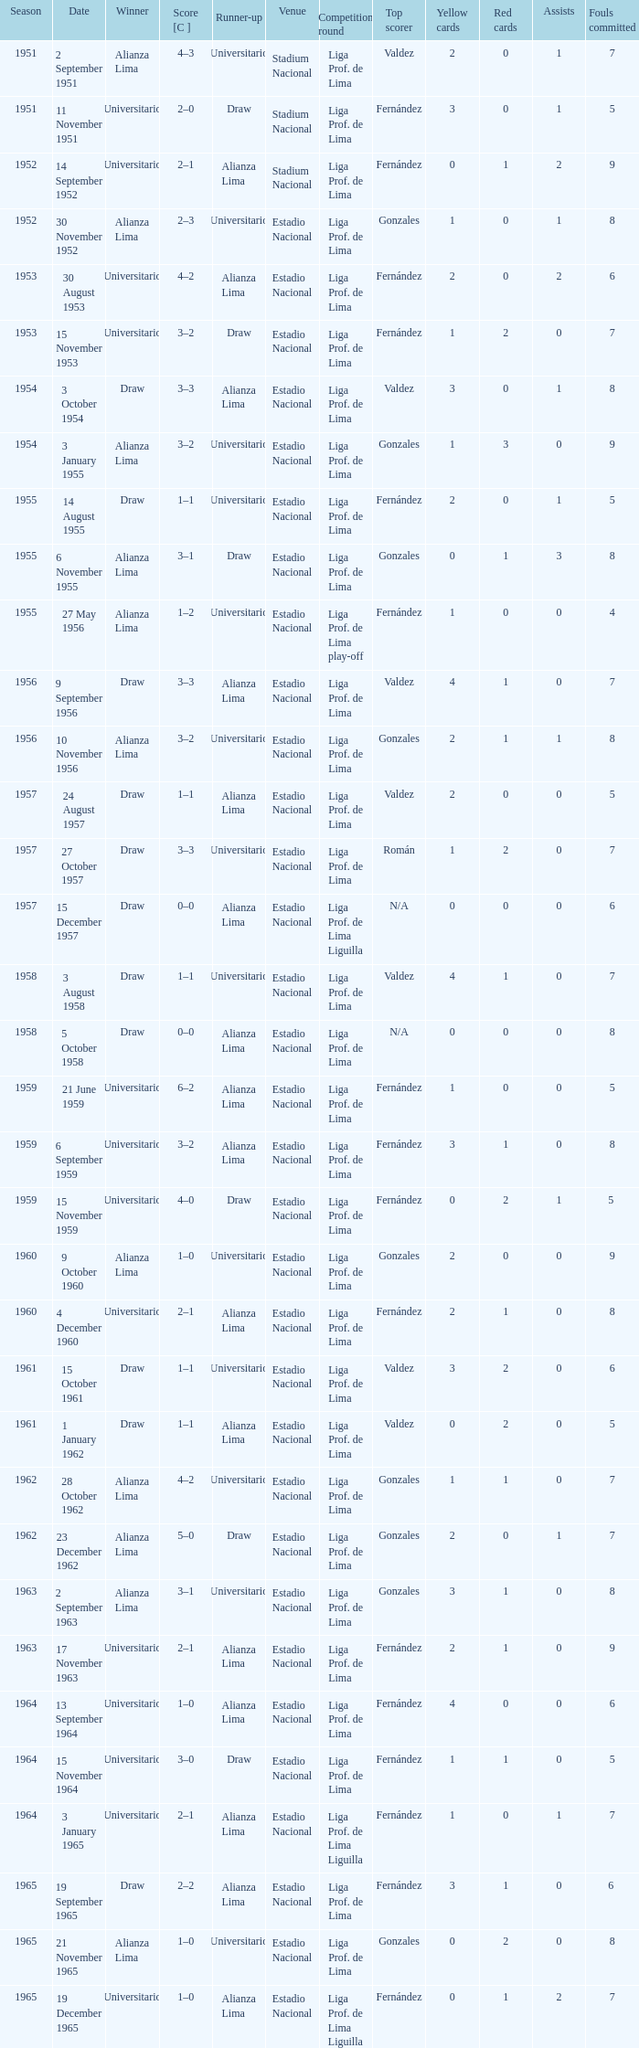What is the most recent season with a date of 27 October 1957? 1957.0. 